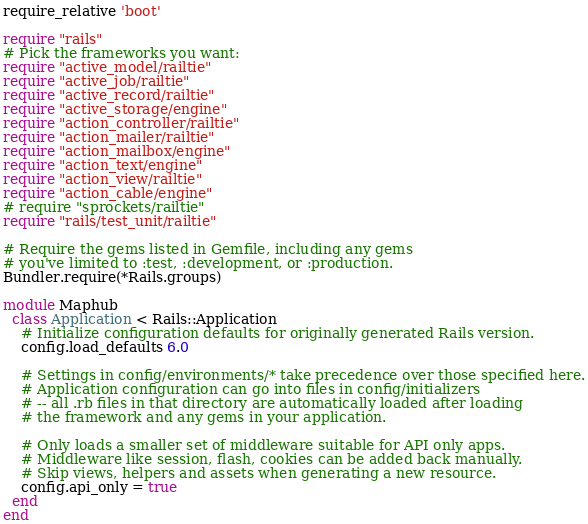<code> <loc_0><loc_0><loc_500><loc_500><_Ruby_>require_relative 'boot'

require "rails"
# Pick the frameworks you want:
require "active_model/railtie"
require "active_job/railtie"
require "active_record/railtie"
require "active_storage/engine"
require "action_controller/railtie"
require "action_mailer/railtie"
require "action_mailbox/engine"
require "action_text/engine"
require "action_view/railtie"
require "action_cable/engine"
# require "sprockets/railtie"
require "rails/test_unit/railtie"

# Require the gems listed in Gemfile, including any gems
# you've limited to :test, :development, or :production.
Bundler.require(*Rails.groups)

module Maphub
  class Application < Rails::Application
    # Initialize configuration defaults for originally generated Rails version.
    config.load_defaults 6.0

    # Settings in config/environments/* take precedence over those specified here.
    # Application configuration can go into files in config/initializers
    # -- all .rb files in that directory are automatically loaded after loading
    # the framework and any gems in your application.

    # Only loads a smaller set of middleware suitable for API only apps.
    # Middleware like session, flash, cookies can be added back manually.
    # Skip views, helpers and assets when generating a new resource.
    config.api_only = true
  end
end
</code> 